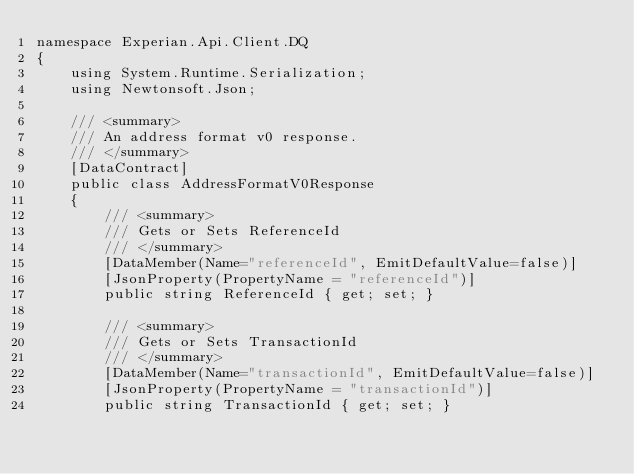Convert code to text. <code><loc_0><loc_0><loc_500><loc_500><_C#_>namespace Experian.Api.Client.DQ
{
    using System.Runtime.Serialization;
    using Newtonsoft.Json;

    /// <summary>
    /// An address format v0 response.
    /// </summary>
    [DataContract]
    public class AddressFormatV0Response
    {
        /// <summary>
        /// Gets or Sets ReferenceId
        /// </summary>
        [DataMember(Name="referenceId", EmitDefaultValue=false)]
        [JsonProperty(PropertyName = "referenceId")]
        public string ReferenceId { get; set; }

        /// <summary>
        /// Gets or Sets TransactionId
        /// </summary>
        [DataMember(Name="transactionId", EmitDefaultValue=false)]
        [JsonProperty(PropertyName = "transactionId")]
        public string TransactionId { get; set; }
</code> 